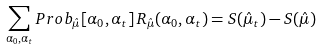Convert formula to latex. <formula><loc_0><loc_0><loc_500><loc_500>\sum _ { \alpha _ { 0 } , \alpha _ { t } } P r o b _ { \hat { \mu } } [ \alpha _ { 0 } , \alpha _ { t } ] \, R _ { \hat { \mu } } ( \alpha _ { 0 } , \alpha _ { t } ) = S ( \hat { \mu } _ { t } ) - S ( \hat { \mu } )</formula> 